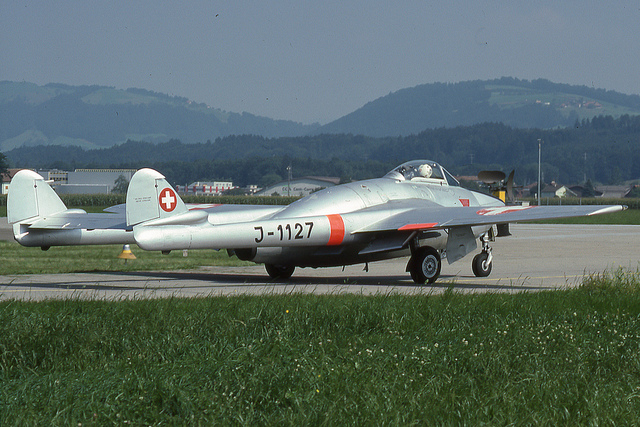Identify the text displayed in this image. J - 1127 